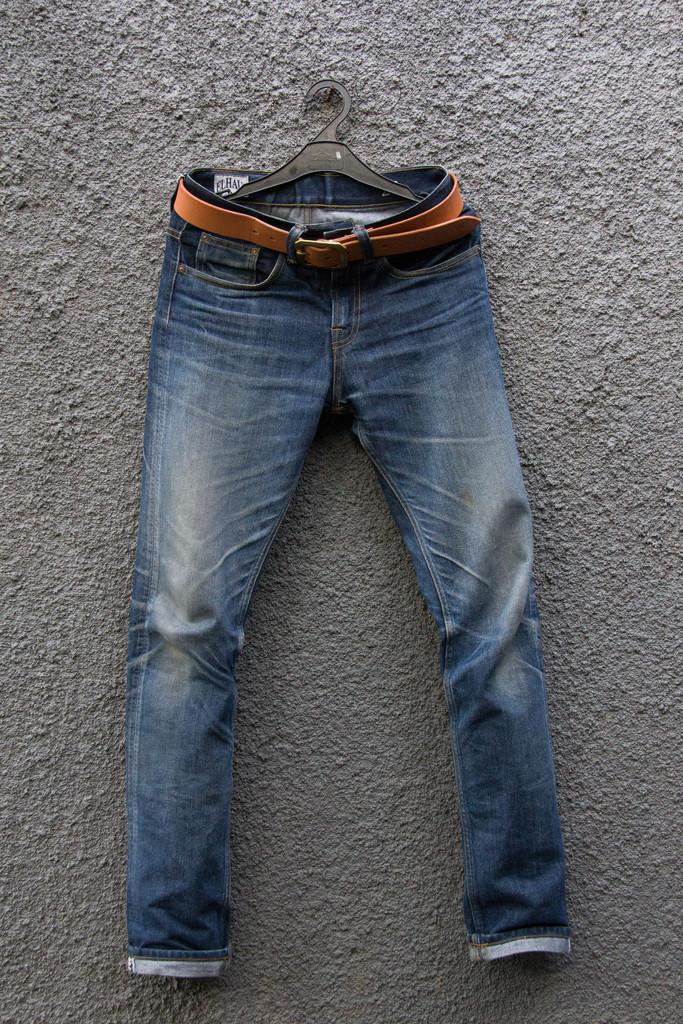What type of clothing item is in the picture? There is a pair of jeans in the picture. How are the jeans positioned in the image? The jeans are hanging on a hanger. What type of dinosaur can be seen wearing the jeans in the image? There are no dinosaurs present in the image, and the jeans are not being worn by any creature. How does the duck interact with the jeans in the image? There are no ducks present in the image, so there is no interaction between a duck and the jeans. 